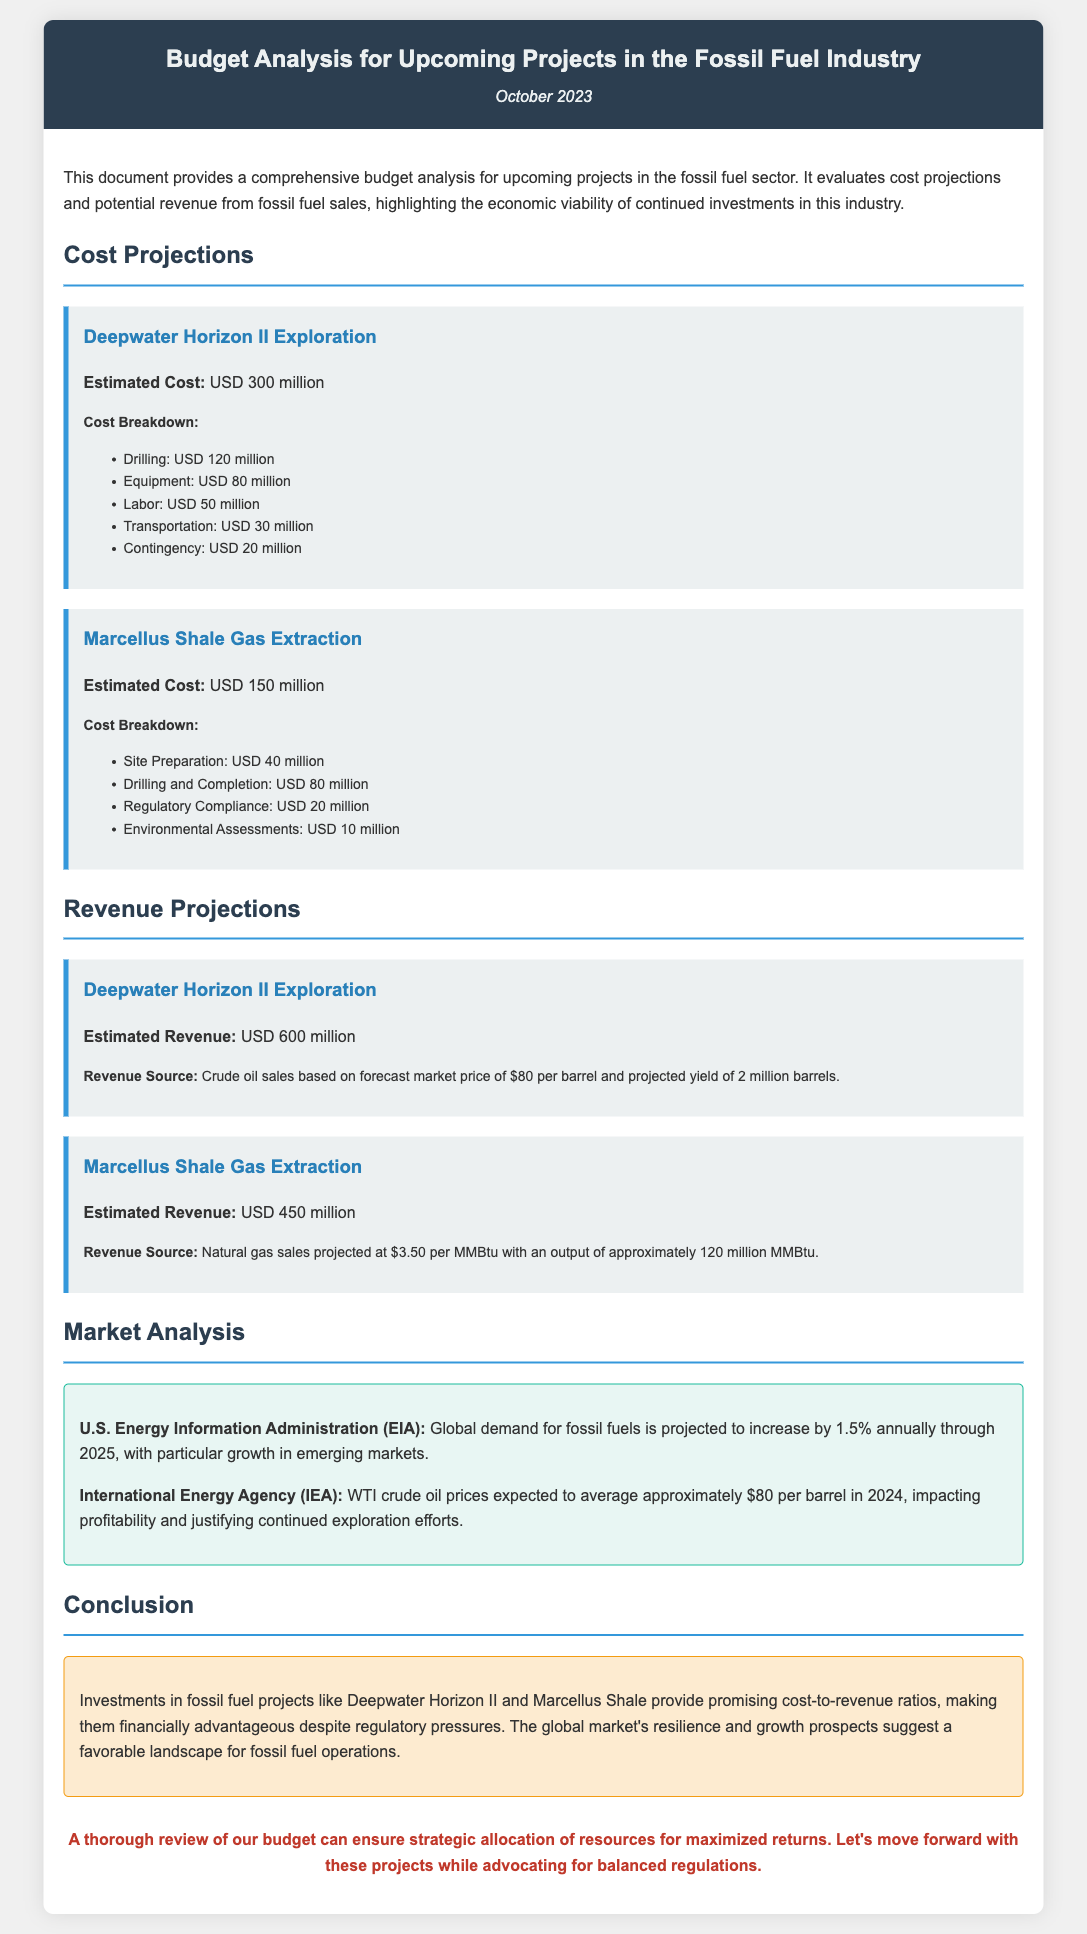what is the estimated cost for Deepwater Horizon II Exploration? The estimated cost for Deepwater Horizon II Exploration is provided in the document as USD 300 million.
Answer: USD 300 million what is the total estimated revenue for Marcellus Shale Gas Extraction? The estimated revenue for Marcellus Shale Gas Extraction is specified as USD 450 million.
Answer: USD 450 million how much is allocated for drilling in the Deepwater Horizon II project cost breakdown? The cost breakdown lists USD 120 million allocated for drilling in the Deepwater Horizon II project.
Answer: USD 120 million which organization provides the projection for global demand for fossil fuels? The document states that the U.S. Energy Information Administration (EIA) provides the projection for global demand for fossil fuels.
Answer: U.S. Energy Information Administration (EIA) what is the projected yield of crude oil for Deepwater Horizon II Exploration? The projected yield of crude oil for Deepwater Horizon II Exploration is stated as 2 million barrels in the document.
Answer: 2 million barrels what is the expected average WTI crude oil price in 2024 according to the International Energy Agency? The International Energy Agency projects that WTI crude oil prices will average approximately USD 80 per barrel in 2024.
Answer: USD 80 per barrel how much is the contingency cost for Deepwater Horizon II project? The contingency cost for Deepwater Horizon II project is listed as USD 20 million in the cost breakdown.
Answer: USD 20 million what percentage is global demand for fossil fuels projected to increase annually? The document states that global demand for fossil fuels is projected to increase by 1.5% annually.
Answer: 1.5% what is the conclusion about the financial advantage of investments in fossil fuel projects? The conclusion highlights that investments in projects like Deepwater Horizon II and Marcellus Shale are financially advantageous despite regulatory pressures.
Answer: financially advantageous 